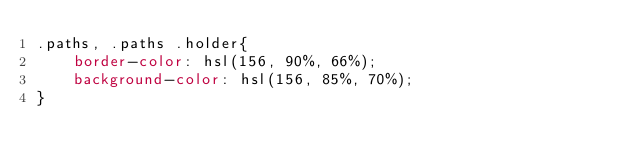Convert code to text. <code><loc_0><loc_0><loc_500><loc_500><_CSS_>.paths, .paths .holder{
    border-color: hsl(156, 90%, 66%);
    background-color: hsl(156, 85%, 70%);
}
</code> 